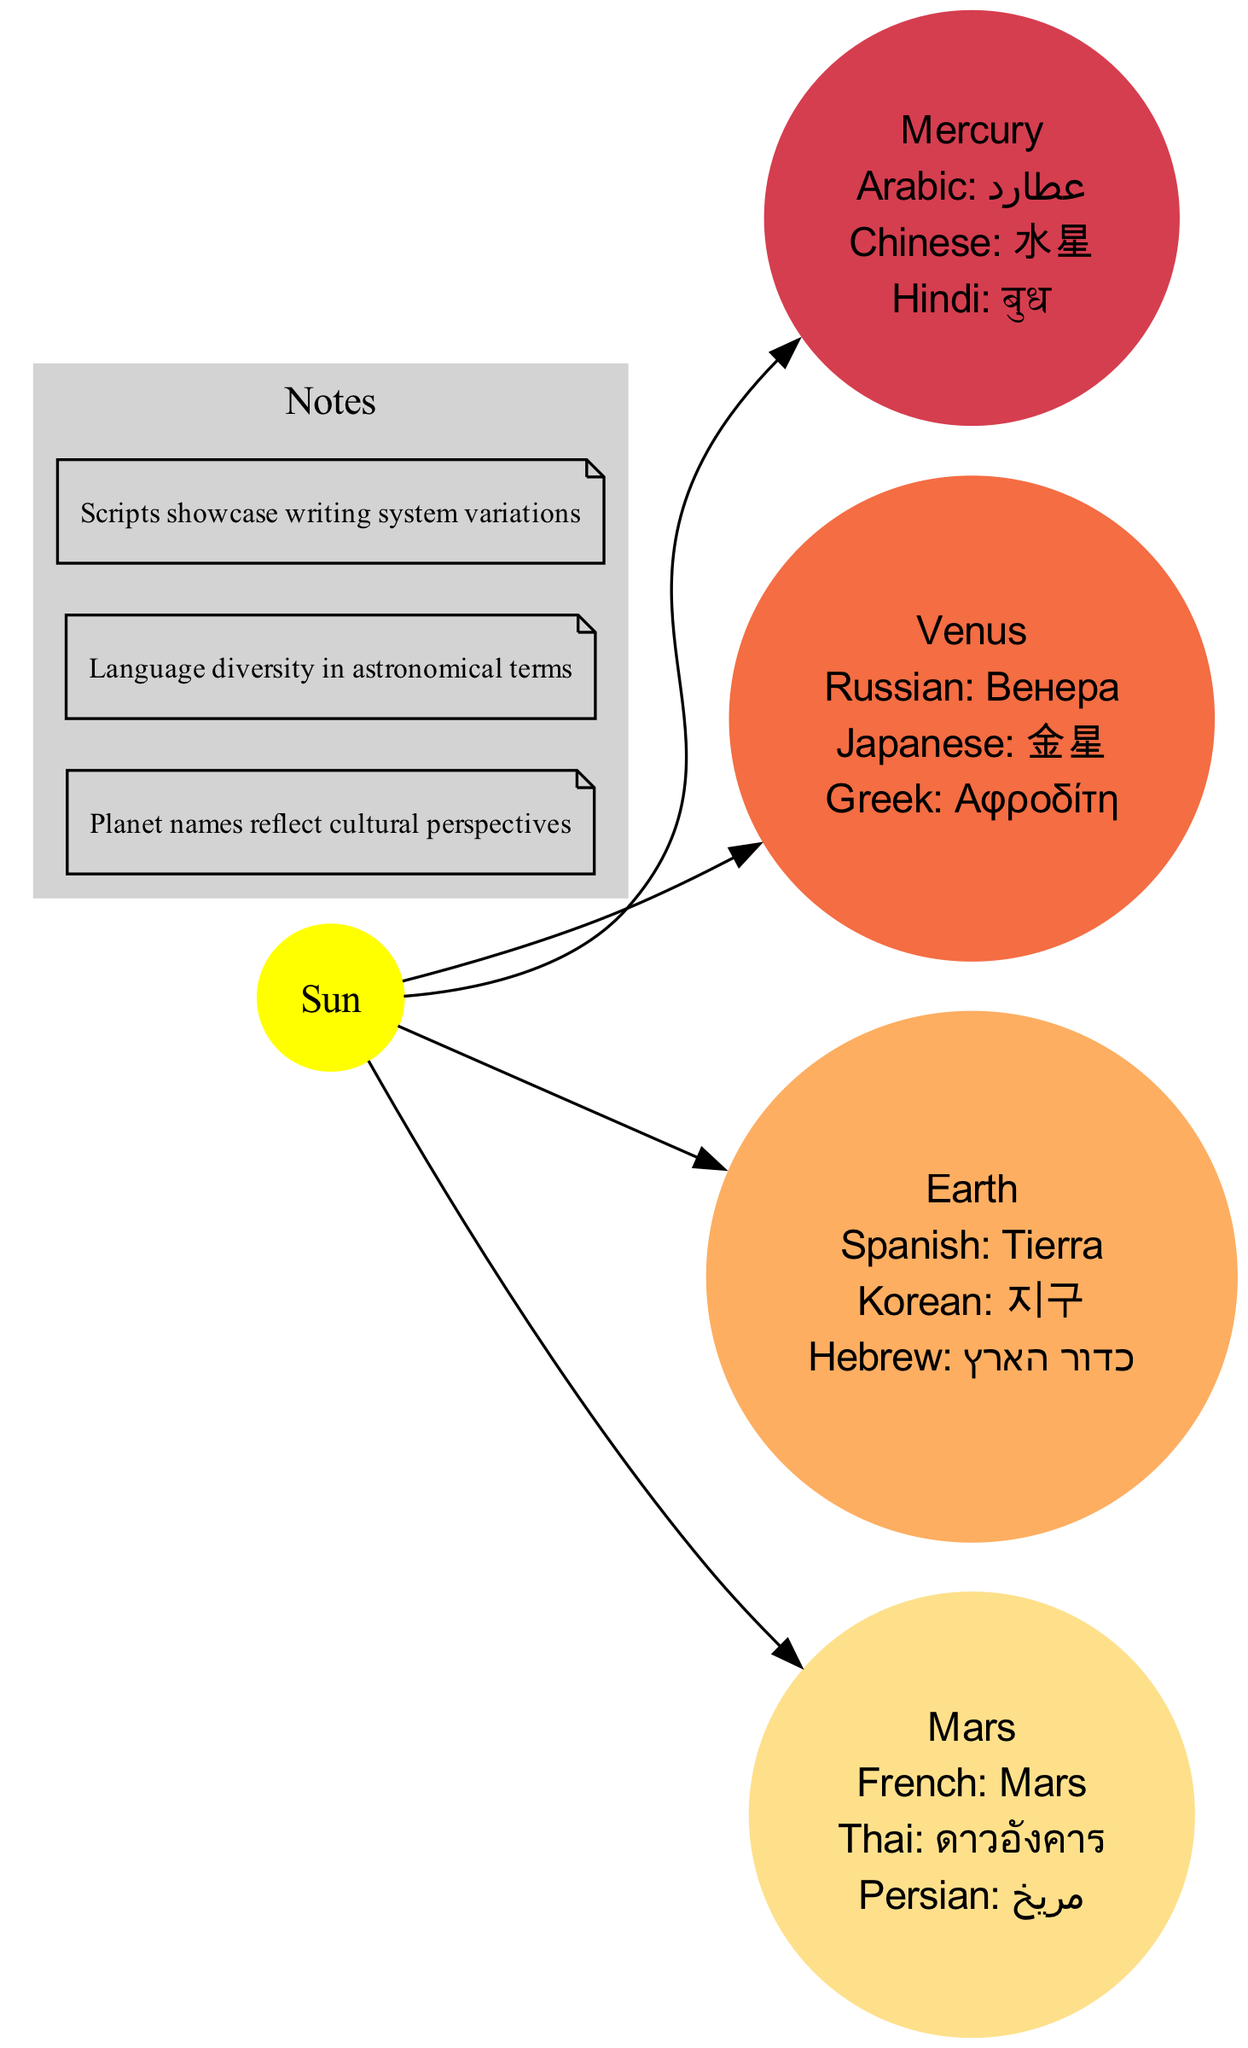what is the name of the planet closest to the Sun? The diagram indicates that the planet closest to the Sun is Mercury.
Answer: Mercury how many planets are shown in the diagram? The diagram includes a total of four planets: Mercury, Venus, Earth, and Mars.
Answer: 4 which language is used to write "Earth" in Hebrew? According to the diagram, Earth is written in Hebrew as "כדור הארץ".
Answer: כדור הארץ what is the script for "Mars" in Thai? The diagram shows that "Mars" in Thai is written as "ดาวอังคาร".
Answer: ดาวอังคาร which planet has the name "Αφροδίτη"? The diagram identifies that the name "Αφροδίτη" corresponds to Venus in the Greek script.
Answer: Venus how many different languages are used to name the planets? The diagram illustrates that there are a total of 12 different languages used to depict the names of the planets.
Answer: 12 what is the color of the Sun node in the diagram? The diagram specifies that the Sun node is filled in yellow color.
Answer: yellow which planet's name appears in both Hindi and Persian? The diagram indicates that the names for Mercury and Mars appear in both Hindi ("बुध") and Persian ("مریخ"). However, specifically, "Mars" is shown in both languages only.
Answer: Mars what is the significance of the notes in the diagram? The notes emphasize the cultural perspectives reflected in planet names, the diversity of languages in astronomical terms, and the various writing systems represented.
Answer: Cultural perspectives 